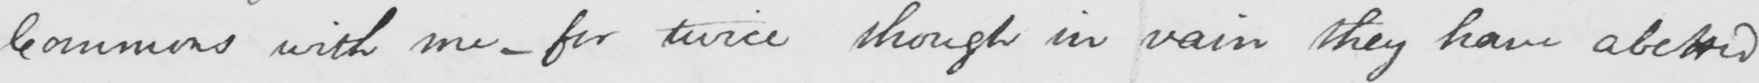What text is written in this handwritten line? Commons with me  _  for twice though in vain they have abetted 